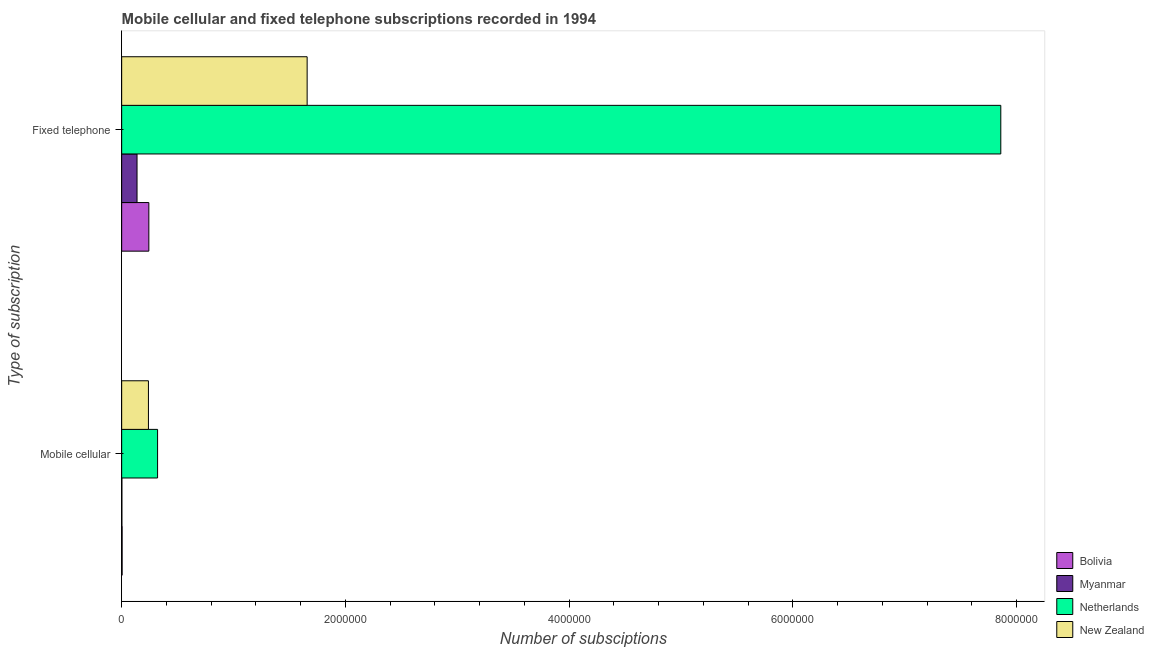How many different coloured bars are there?
Offer a terse response. 4. How many groups of bars are there?
Provide a succinct answer. 2. Are the number of bars on each tick of the Y-axis equal?
Offer a very short reply. Yes. How many bars are there on the 2nd tick from the bottom?
Ensure brevity in your answer.  4. What is the label of the 1st group of bars from the top?
Make the answer very short. Fixed telephone. What is the number of fixed telephone subscriptions in Bolivia?
Provide a short and direct response. 2.43e+05. Across all countries, what is the maximum number of mobile cellular subscriptions?
Make the answer very short. 3.21e+05. Across all countries, what is the minimum number of mobile cellular subscriptions?
Provide a short and direct response. 1920. In which country was the number of mobile cellular subscriptions minimum?
Keep it short and to the point. Myanmar. What is the total number of mobile cellular subscriptions in the graph?
Your answer should be compact. 5.66e+05. What is the difference between the number of mobile cellular subscriptions in Netherlands and that in Myanmar?
Provide a succinct answer. 3.19e+05. What is the difference between the number of fixed telephone subscriptions in Myanmar and the number of mobile cellular subscriptions in Netherlands?
Your answer should be very brief. -1.84e+05. What is the average number of mobile cellular subscriptions per country?
Make the answer very short. 1.42e+05. What is the difference between the number of fixed telephone subscriptions and number of mobile cellular subscriptions in New Zealand?
Offer a very short reply. 1.42e+06. In how many countries, is the number of mobile cellular subscriptions greater than 5600000 ?
Your answer should be very brief. 0. What is the ratio of the number of mobile cellular subscriptions in Netherlands to that in Myanmar?
Ensure brevity in your answer.  167.19. Is the number of mobile cellular subscriptions in New Zealand less than that in Bolivia?
Offer a very short reply. No. In how many countries, is the number of fixed telephone subscriptions greater than the average number of fixed telephone subscriptions taken over all countries?
Provide a succinct answer. 1. What does the 3rd bar from the top in Mobile cellular represents?
Ensure brevity in your answer.  Myanmar. What does the 4th bar from the bottom in Mobile cellular represents?
Give a very brief answer. New Zealand. How many bars are there?
Your answer should be very brief. 8. What is the difference between two consecutive major ticks on the X-axis?
Make the answer very short. 2.00e+06. How many legend labels are there?
Ensure brevity in your answer.  4. How are the legend labels stacked?
Keep it short and to the point. Vertical. What is the title of the graph?
Provide a succinct answer. Mobile cellular and fixed telephone subscriptions recorded in 1994. What is the label or title of the X-axis?
Your response must be concise. Number of subsciptions. What is the label or title of the Y-axis?
Offer a terse response. Type of subscription. What is the Number of subsciptions of Bolivia in Mobile cellular?
Your answer should be very brief. 4056. What is the Number of subsciptions in Myanmar in Mobile cellular?
Offer a very short reply. 1920. What is the Number of subsciptions of Netherlands in Mobile cellular?
Your answer should be compact. 3.21e+05. What is the Number of subsciptions in New Zealand in Mobile cellular?
Your answer should be very brief. 2.39e+05. What is the Number of subsciptions in Bolivia in Fixed telephone?
Provide a succinct answer. 2.43e+05. What is the Number of subsciptions in Myanmar in Fixed telephone?
Your response must be concise. 1.37e+05. What is the Number of subsciptions in Netherlands in Fixed telephone?
Make the answer very short. 7.86e+06. What is the Number of subsciptions of New Zealand in Fixed telephone?
Make the answer very short. 1.66e+06. Across all Type of subscription, what is the maximum Number of subsciptions in Bolivia?
Provide a short and direct response. 2.43e+05. Across all Type of subscription, what is the maximum Number of subsciptions of Myanmar?
Offer a very short reply. 1.37e+05. Across all Type of subscription, what is the maximum Number of subsciptions in Netherlands?
Provide a short and direct response. 7.86e+06. Across all Type of subscription, what is the maximum Number of subsciptions of New Zealand?
Your answer should be compact. 1.66e+06. Across all Type of subscription, what is the minimum Number of subsciptions in Bolivia?
Your response must be concise. 4056. Across all Type of subscription, what is the minimum Number of subsciptions of Myanmar?
Offer a very short reply. 1920. Across all Type of subscription, what is the minimum Number of subsciptions of Netherlands?
Give a very brief answer. 3.21e+05. Across all Type of subscription, what is the minimum Number of subsciptions in New Zealand?
Make the answer very short. 2.39e+05. What is the total Number of subsciptions of Bolivia in the graph?
Your answer should be very brief. 2.47e+05. What is the total Number of subsciptions in Myanmar in the graph?
Keep it short and to the point. 1.39e+05. What is the total Number of subsciptions in Netherlands in the graph?
Provide a succinct answer. 8.18e+06. What is the total Number of subsciptions of New Zealand in the graph?
Your answer should be compact. 1.90e+06. What is the difference between the Number of subsciptions in Bolivia in Mobile cellular and that in Fixed telephone?
Make the answer very short. -2.39e+05. What is the difference between the Number of subsciptions of Myanmar in Mobile cellular and that in Fixed telephone?
Your response must be concise. -1.35e+05. What is the difference between the Number of subsciptions in Netherlands in Mobile cellular and that in Fixed telephone?
Offer a very short reply. -7.54e+06. What is the difference between the Number of subsciptions in New Zealand in Mobile cellular and that in Fixed telephone?
Provide a short and direct response. -1.42e+06. What is the difference between the Number of subsciptions in Bolivia in Mobile cellular and the Number of subsciptions in Myanmar in Fixed telephone?
Ensure brevity in your answer.  -1.33e+05. What is the difference between the Number of subsciptions in Bolivia in Mobile cellular and the Number of subsciptions in Netherlands in Fixed telephone?
Ensure brevity in your answer.  -7.85e+06. What is the difference between the Number of subsciptions in Bolivia in Mobile cellular and the Number of subsciptions in New Zealand in Fixed telephone?
Your response must be concise. -1.65e+06. What is the difference between the Number of subsciptions in Myanmar in Mobile cellular and the Number of subsciptions in Netherlands in Fixed telephone?
Provide a succinct answer. -7.86e+06. What is the difference between the Number of subsciptions of Myanmar in Mobile cellular and the Number of subsciptions of New Zealand in Fixed telephone?
Provide a short and direct response. -1.66e+06. What is the difference between the Number of subsciptions in Netherlands in Mobile cellular and the Number of subsciptions in New Zealand in Fixed telephone?
Provide a succinct answer. -1.34e+06. What is the average Number of subsciptions in Bolivia per Type of subscription?
Ensure brevity in your answer.  1.23e+05. What is the average Number of subsciptions of Myanmar per Type of subscription?
Your answer should be very brief. 6.96e+04. What is the average Number of subsciptions in Netherlands per Type of subscription?
Provide a succinct answer. 4.09e+06. What is the average Number of subsciptions of New Zealand per Type of subscription?
Offer a very short reply. 9.49e+05. What is the difference between the Number of subsciptions in Bolivia and Number of subsciptions in Myanmar in Mobile cellular?
Your response must be concise. 2136. What is the difference between the Number of subsciptions of Bolivia and Number of subsciptions of Netherlands in Mobile cellular?
Make the answer very short. -3.17e+05. What is the difference between the Number of subsciptions in Bolivia and Number of subsciptions in New Zealand in Mobile cellular?
Make the answer very short. -2.35e+05. What is the difference between the Number of subsciptions of Myanmar and Number of subsciptions of Netherlands in Mobile cellular?
Your response must be concise. -3.19e+05. What is the difference between the Number of subsciptions in Myanmar and Number of subsciptions in New Zealand in Mobile cellular?
Your response must be concise. -2.37e+05. What is the difference between the Number of subsciptions in Netherlands and Number of subsciptions in New Zealand in Mobile cellular?
Keep it short and to the point. 8.18e+04. What is the difference between the Number of subsciptions in Bolivia and Number of subsciptions in Myanmar in Fixed telephone?
Provide a succinct answer. 1.05e+05. What is the difference between the Number of subsciptions in Bolivia and Number of subsciptions in Netherlands in Fixed telephone?
Offer a very short reply. -7.62e+06. What is the difference between the Number of subsciptions of Bolivia and Number of subsciptions of New Zealand in Fixed telephone?
Your answer should be very brief. -1.42e+06. What is the difference between the Number of subsciptions in Myanmar and Number of subsciptions in Netherlands in Fixed telephone?
Your answer should be very brief. -7.72e+06. What is the difference between the Number of subsciptions in Myanmar and Number of subsciptions in New Zealand in Fixed telephone?
Keep it short and to the point. -1.52e+06. What is the difference between the Number of subsciptions of Netherlands and Number of subsciptions of New Zealand in Fixed telephone?
Offer a terse response. 6.20e+06. What is the ratio of the Number of subsciptions of Bolivia in Mobile cellular to that in Fixed telephone?
Offer a terse response. 0.02. What is the ratio of the Number of subsciptions of Myanmar in Mobile cellular to that in Fixed telephone?
Offer a very short reply. 0.01. What is the ratio of the Number of subsciptions in Netherlands in Mobile cellular to that in Fixed telephone?
Your answer should be compact. 0.04. What is the ratio of the Number of subsciptions of New Zealand in Mobile cellular to that in Fixed telephone?
Ensure brevity in your answer.  0.14. What is the difference between the highest and the second highest Number of subsciptions of Bolivia?
Offer a very short reply. 2.39e+05. What is the difference between the highest and the second highest Number of subsciptions of Myanmar?
Make the answer very short. 1.35e+05. What is the difference between the highest and the second highest Number of subsciptions of Netherlands?
Provide a succinct answer. 7.54e+06. What is the difference between the highest and the second highest Number of subsciptions in New Zealand?
Keep it short and to the point. 1.42e+06. What is the difference between the highest and the lowest Number of subsciptions of Bolivia?
Give a very brief answer. 2.39e+05. What is the difference between the highest and the lowest Number of subsciptions of Myanmar?
Provide a succinct answer. 1.35e+05. What is the difference between the highest and the lowest Number of subsciptions in Netherlands?
Provide a succinct answer. 7.54e+06. What is the difference between the highest and the lowest Number of subsciptions in New Zealand?
Your answer should be compact. 1.42e+06. 